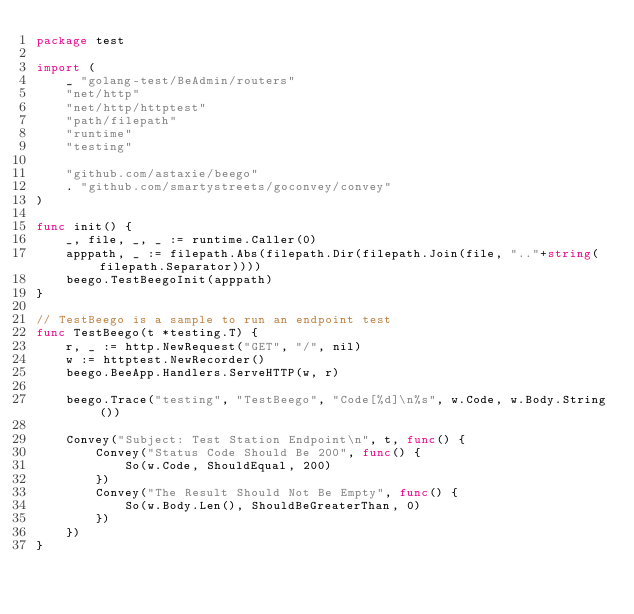<code> <loc_0><loc_0><loc_500><loc_500><_Go_>package test

import (
	_ "golang-test/BeAdmin/routers"
	"net/http"
	"net/http/httptest"
	"path/filepath"
	"runtime"
	"testing"

	"github.com/astaxie/beego"
	. "github.com/smartystreets/goconvey/convey"
)

func init() {
	_, file, _, _ := runtime.Caller(0)
	apppath, _ := filepath.Abs(filepath.Dir(filepath.Join(file, ".."+string(filepath.Separator))))
	beego.TestBeegoInit(apppath)
}

// TestBeego is a sample to run an endpoint test
func TestBeego(t *testing.T) {
	r, _ := http.NewRequest("GET", "/", nil)
	w := httptest.NewRecorder()
	beego.BeeApp.Handlers.ServeHTTP(w, r)

	beego.Trace("testing", "TestBeego", "Code[%d]\n%s", w.Code, w.Body.String())

	Convey("Subject: Test Station Endpoint\n", t, func() {
		Convey("Status Code Should Be 200", func() {
			So(w.Code, ShouldEqual, 200)
		})
		Convey("The Result Should Not Be Empty", func() {
			So(w.Body.Len(), ShouldBeGreaterThan, 0)
		})
	})
}
</code> 